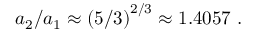<formula> <loc_0><loc_0><loc_500><loc_500>a _ { 2 } / a _ { 1 } \approx \left ( 5 / 3 \right ) ^ { 2 / 3 } \approx 1 . 4 0 5 7 \ .</formula> 